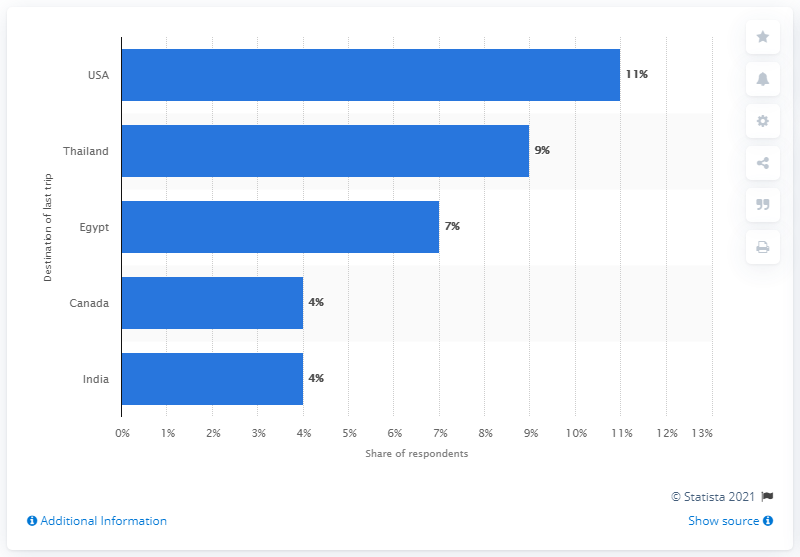Indicate a few pertinent items in this graphic. In 2017, it was reported that approximately 11% of Europeans had visited the United States. 